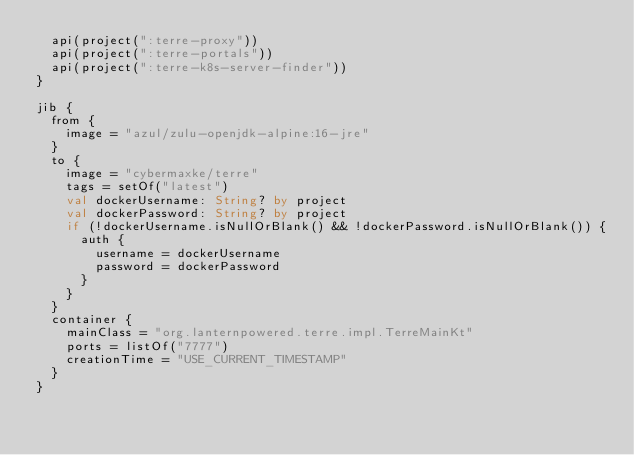<code> <loc_0><loc_0><loc_500><loc_500><_Kotlin_>  api(project(":terre-proxy"))
  api(project(":terre-portals"))
  api(project(":terre-k8s-server-finder"))
}

jib {
  from {
    image = "azul/zulu-openjdk-alpine:16-jre"
  }
  to {
    image = "cybermaxke/terre"
    tags = setOf("latest")
    val dockerUsername: String? by project
    val dockerPassword: String? by project
    if (!dockerUsername.isNullOrBlank() && !dockerPassword.isNullOrBlank()) {
      auth {
        username = dockerUsername
        password = dockerPassword
      }
    }
  }
  container {
    mainClass = "org.lanternpowered.terre.impl.TerreMainKt"
    ports = listOf("7777")
    creationTime = "USE_CURRENT_TIMESTAMP"
  }
}
</code> 